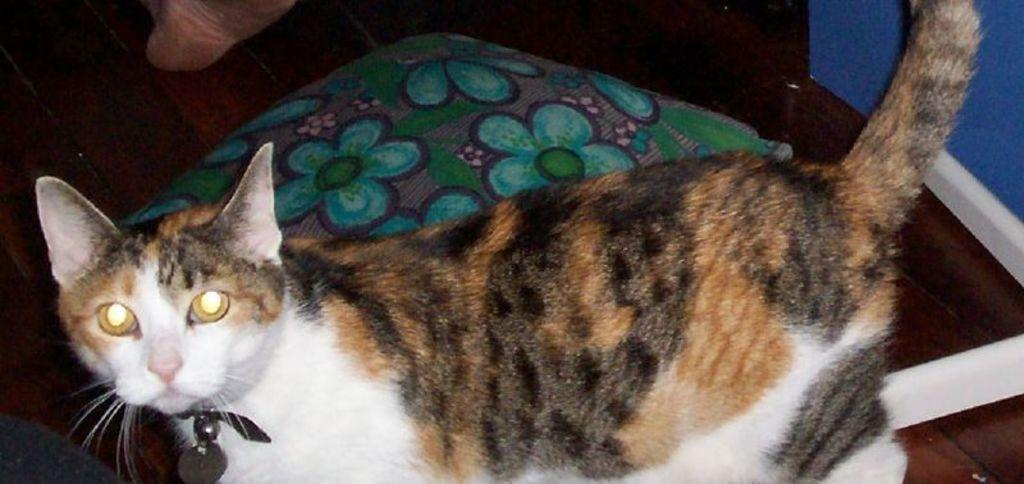What type of animal is present in the image? There is a cat in the image. Can you describe the color pattern of the cat? The cat has brown, black, and white colors. What other object is visible in the image? There is a pillow in the image. What type of house does the cat claim as its territory in the image? There is no house or territory mentioned in the image; it only features a cat and a pillow. 